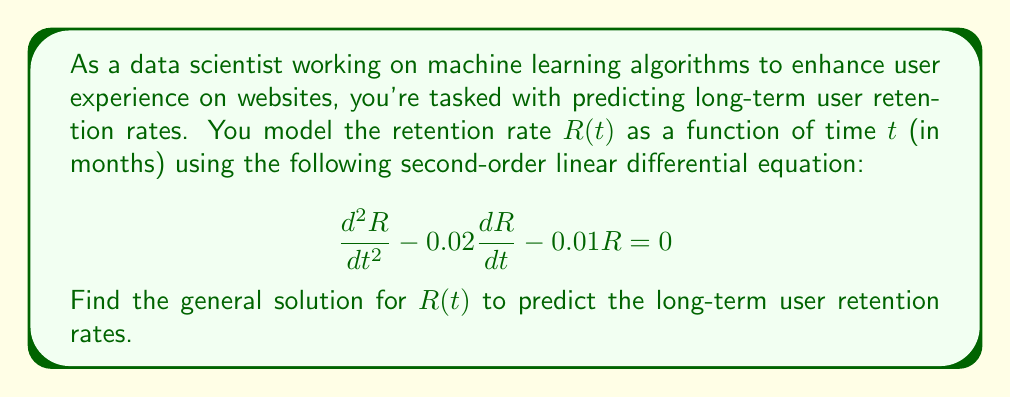What is the answer to this math problem? To solve this second-order linear differential equation, we follow these steps:

1) First, we assume a solution of the form $R(t) = e^{rt}$, where $r$ is a constant to be determined.

2) Substituting this into the differential equation:

   $$r^2e^{rt} - 0.02re^{rt} - 0.01e^{rt} = 0$$

3) Factoring out $e^{rt}$:

   $$e^{rt}(r^2 - 0.02r - 0.01) = 0$$

4) Since $e^{rt} \neq 0$ for any finite $t$, we solve the characteristic equation:

   $$r^2 - 0.02r - 0.01 = 0$$

5) This is a quadratic equation. We can solve it using the quadratic formula:

   $$r = \frac{-b \pm \sqrt{b^2 - 4ac}}{2a}$$

   Where $a=1$, $b=-0.02$, and $c=-0.01$

6) Substituting these values:

   $$r = \frac{0.02 \pm \sqrt{(-0.02)^2 - 4(1)(-0.01)}}{2(1)}$$
   
   $$= \frac{0.02 \pm \sqrt{0.0004 + 0.04}}{2}$$
   
   $$= \frac{0.02 \pm \sqrt{0.0404}}{2}$$
   
   $$= \frac{0.02 \pm 0.2010}{2}$$

7) This gives us two roots:

   $$r_1 = \frac{0.02 + 0.2010}{2} = 0.1105$$
   
   $$r_2 = \frac{0.02 - 0.2010}{2} = -0.0905$$

8) The general solution is a linear combination of the two fundamental solutions:

   $$R(t) = c_1e^{r_1t} + c_2e^{r_2t}$$

   Where $c_1$ and $c_2$ are arbitrary constants.

9) Substituting the values of $r_1$ and $r_2$:

   $$R(t) = c_1e^{0.1105t} + c_2e^{-0.0905t}$$

This is the general solution for the user retention rate as a function of time.
Answer: $$R(t) = c_1e^{0.1105t} + c_2e^{-0.0905t}$$
Where $c_1$ and $c_2$ are arbitrary constants determined by initial conditions. 